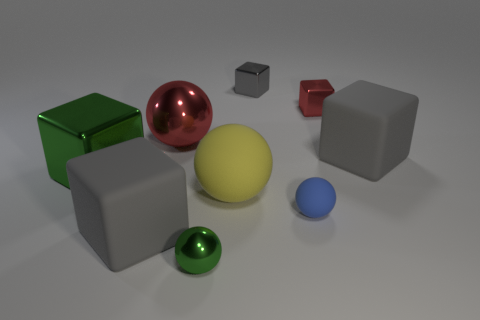Subtract all green cylinders. How many gray blocks are left? 3 Subtract all blue spheres. How many spheres are left? 3 Subtract all big metal cubes. How many cubes are left? 4 Subtract all brown cubes. Subtract all brown cylinders. How many cubes are left? 5 Add 1 small red metal blocks. How many objects exist? 10 Subtract all cubes. How many objects are left? 4 Add 1 small metallic cubes. How many small metallic cubes exist? 3 Subtract 0 yellow cubes. How many objects are left? 9 Subtract all tiny gray shiny cubes. Subtract all big rubber objects. How many objects are left? 5 Add 4 green shiny balls. How many green shiny balls are left? 5 